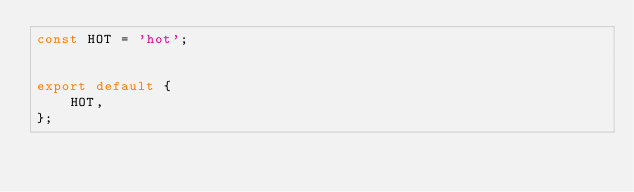<code> <loc_0><loc_0><loc_500><loc_500><_JavaScript_>const HOT = 'hot';


export default {
    HOT,
};</code> 